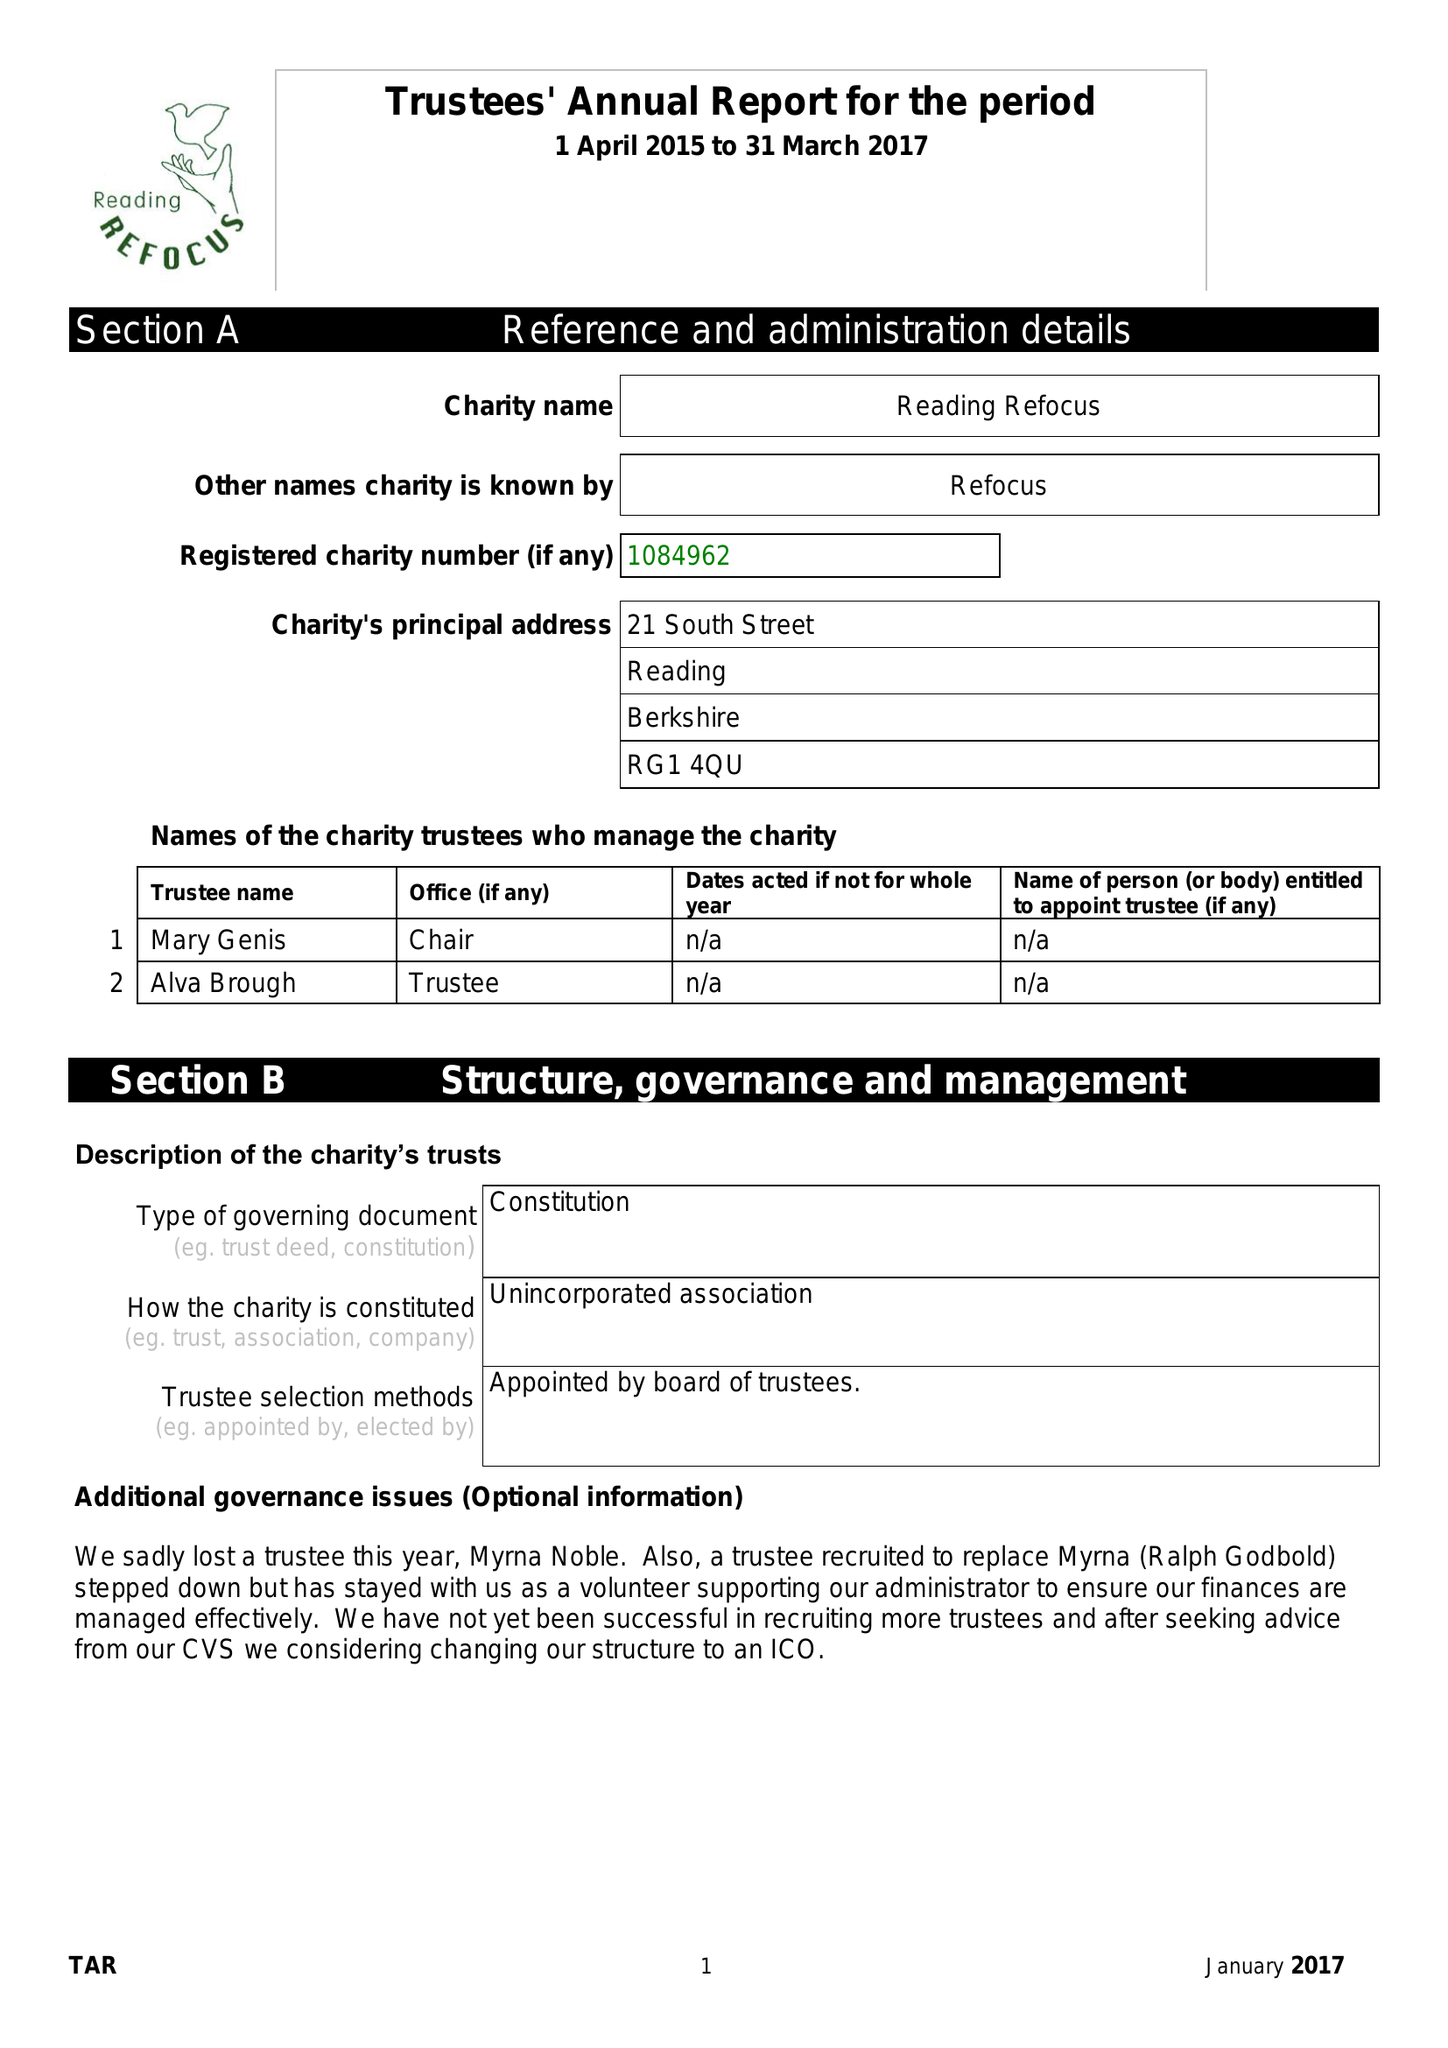What is the value for the charity_number?
Answer the question using a single word or phrase. 1048962 